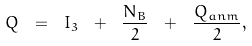Convert formula to latex. <formula><loc_0><loc_0><loc_500><loc_500>Q \ = \ I _ { 3 } \ + \ \frac { N _ { B } } { 2 } \ + \ \frac { Q _ { a n m } } { 2 } ,</formula> 